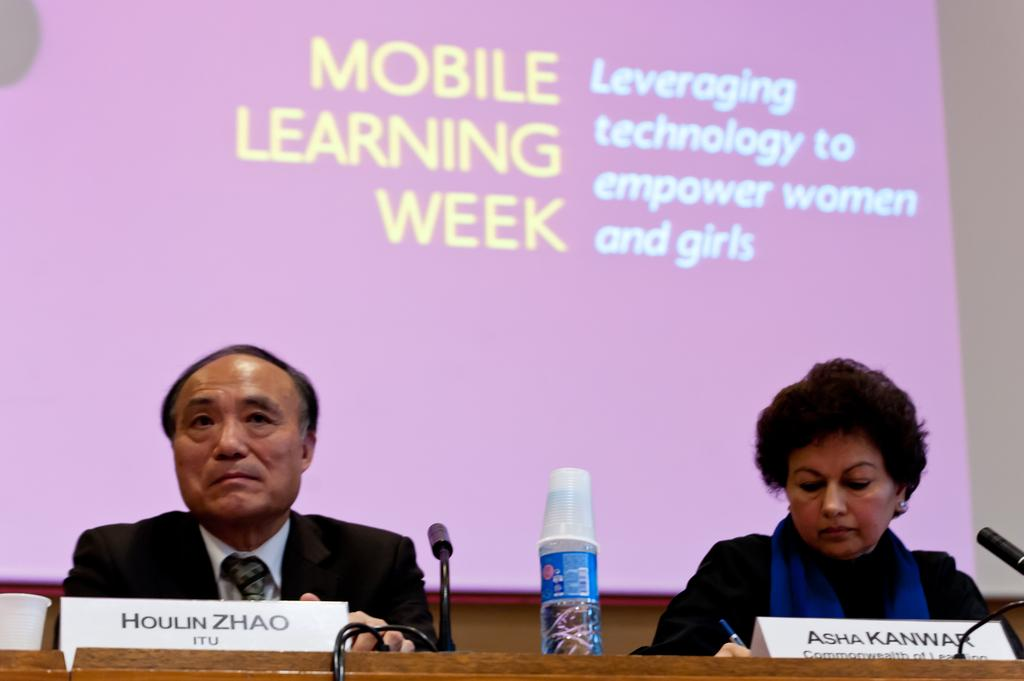Provide a one-sentence caption for the provided image. Houlin Zhao of ITU and Asha Kanwar of one of the commonwealths attended Mobile Learning Week where the emphasis was leveraging technology to empower women and girls. 